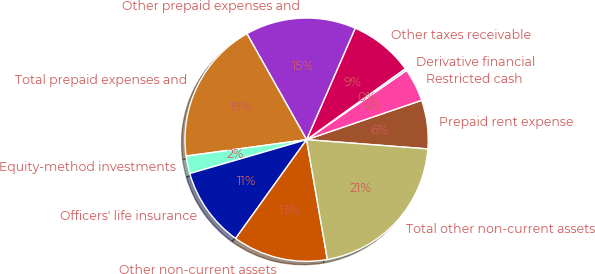<chart> <loc_0><loc_0><loc_500><loc_500><pie_chart><fcel>Prepaid rent expense<fcel>Restricted cash<fcel>Derivative financial<fcel>Other taxes receivable<fcel>Other prepaid expenses and<fcel>Total prepaid expenses and<fcel>Equity-method investments<fcel>Officers' life insurance<fcel>Other non-current assets<fcel>Total other non-current assets<nl><fcel>6.46%<fcel>4.4%<fcel>0.28%<fcel>8.53%<fcel>14.71%<fcel>18.99%<fcel>2.34%<fcel>10.59%<fcel>12.65%<fcel>21.05%<nl></chart> 